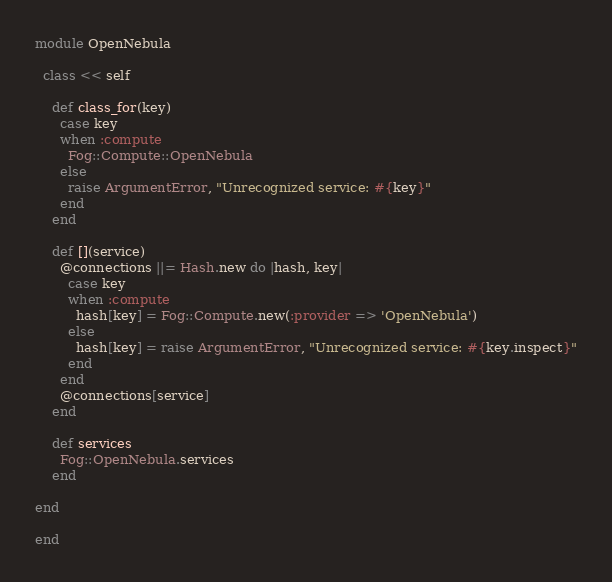<code> <loc_0><loc_0><loc_500><loc_500><_Ruby_>module OpenNebula

  class << self

    def class_for(key)
      case key
      when :compute
        Fog::Compute::OpenNebula
      else
        raise ArgumentError, "Unrecognized service: #{key}"
      end
    end

    def [](service)
      @connections ||= Hash.new do |hash, key|
        case key
        when :compute
          hash[key] = Fog::Compute.new(:provider => 'OpenNebula')
        else
          hash[key] = raise ArgumentError, "Unrecognized service: #{key.inspect}"
        end
      end
      @connections[service]
    end

    def services
      Fog::OpenNebula.services
    end

end

end
</code> 